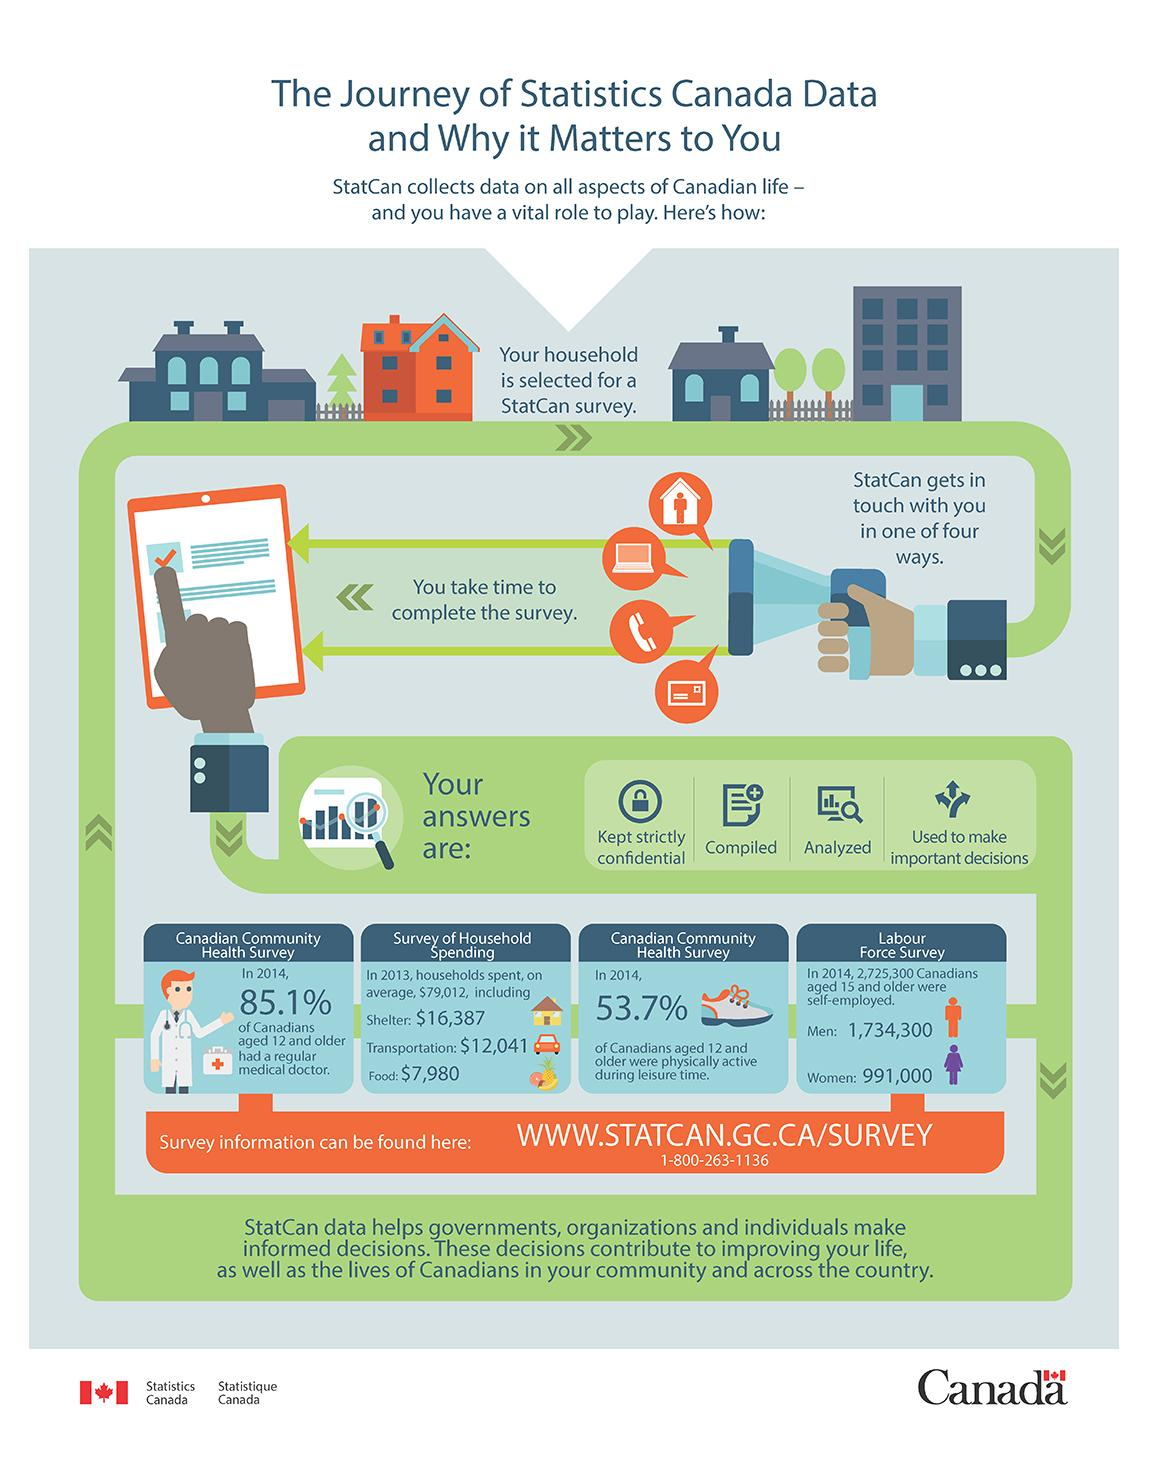Identify some key points in this picture. In 2014, according to the Labour Force Survey, 991,000 Canadian women aged 15 years and older were self-employed. According to the Canadian Health Survey in 2014, approximately 14.9% of Canadians aged 12 and older did not have a regular medical doctor. The average household in Canada spent approximately $7,980 on food in 2013, according to a survey of household spending. 